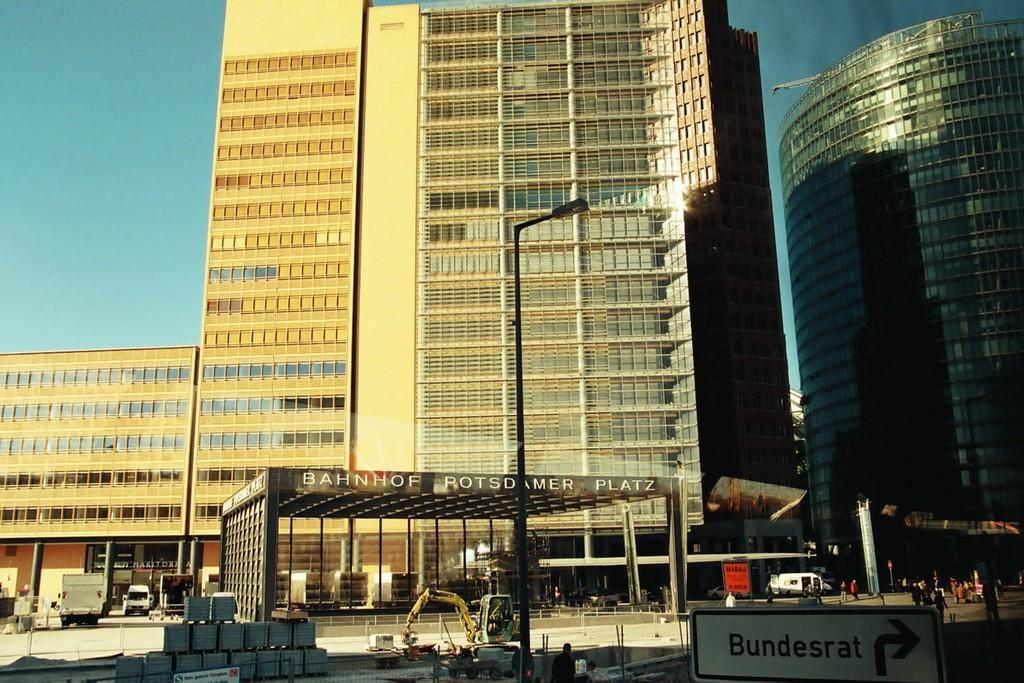What type of structures can be seen in the image? There are buildings in the image. What is visible in the background of the image? The sky is visible behind the buildings. What is a prominent feature on the buildings? There is a sign board on one of the buildings. What type of transportation is present in the image? Vehicles are present in the image. Are there any people visible in the image? Yes, there are persons in the image. What else can be seen in the image besides buildings and people? A pole is visible in the image. What shape are some of the objects in the image? There are rectangular shaped things in the image. Can you tell me how many crates are stacked on the pump in the image? There is no pump or crate present in the image. What type of driving is happening in the image? There is no driving activity depicted in the image. 